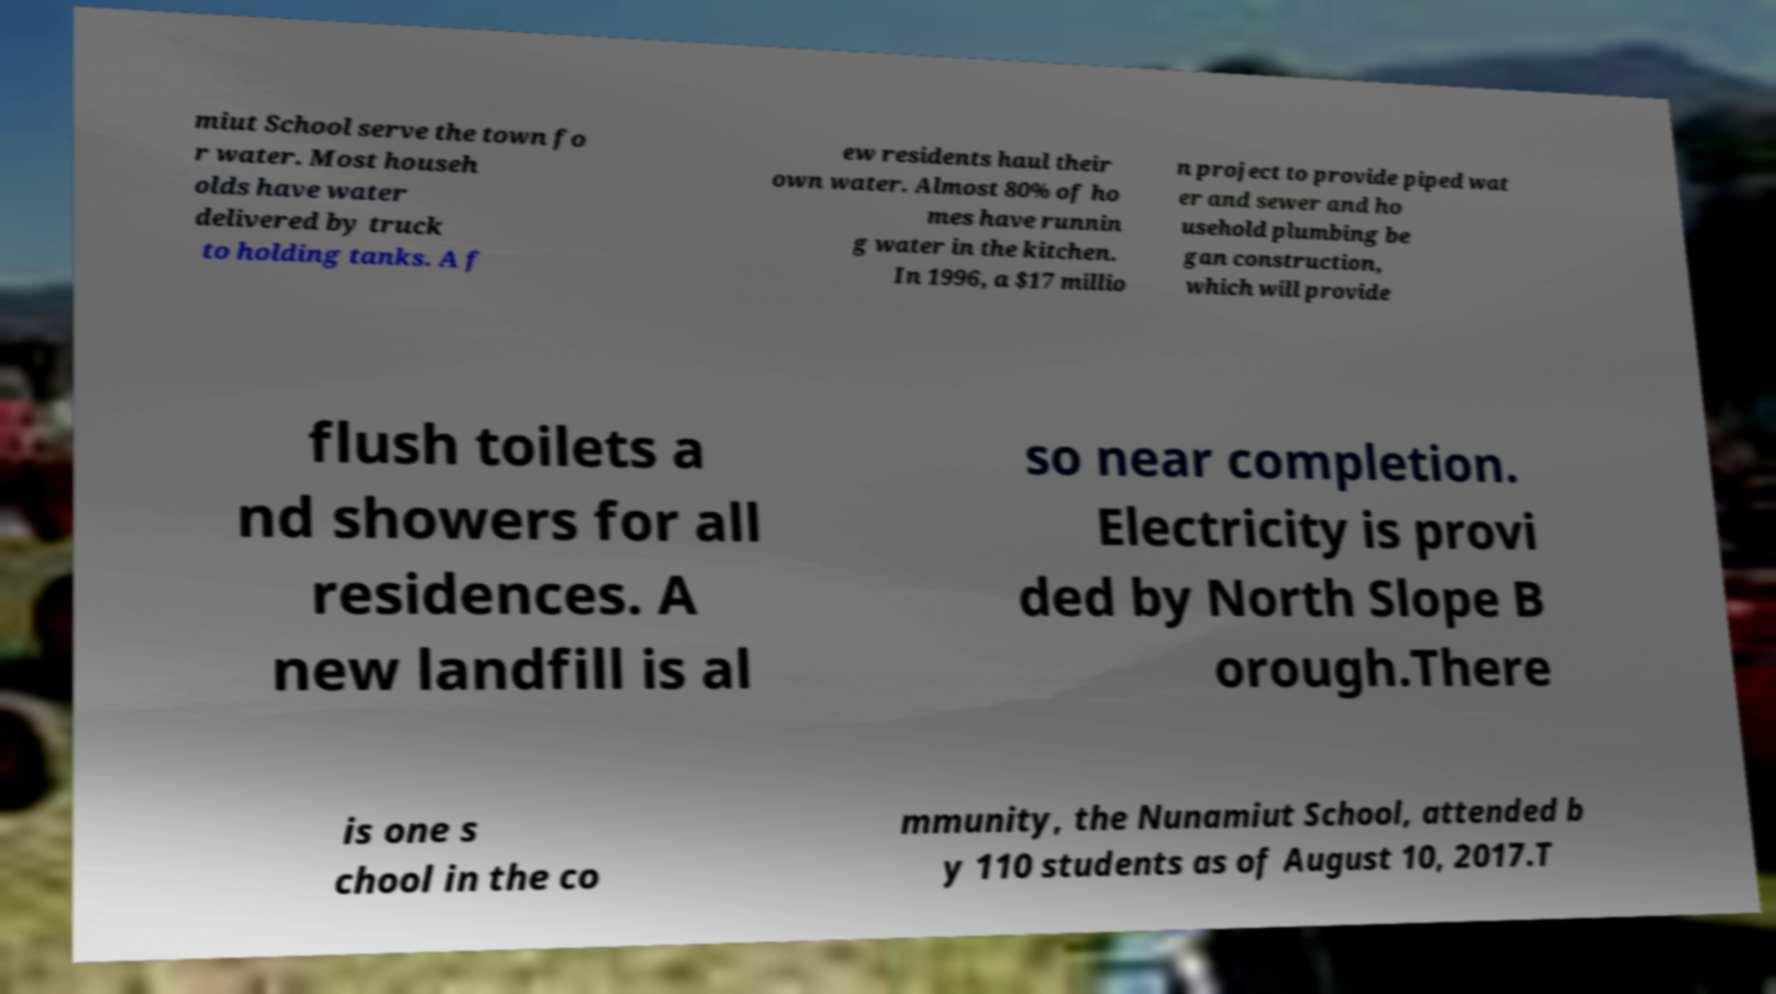What messages or text are displayed in this image? I need them in a readable, typed format. miut School serve the town fo r water. Most househ olds have water delivered by truck to holding tanks. A f ew residents haul their own water. Almost 80% of ho mes have runnin g water in the kitchen. In 1996, a $17 millio n project to provide piped wat er and sewer and ho usehold plumbing be gan construction, which will provide flush toilets a nd showers for all residences. A new landfill is al so near completion. Electricity is provi ded by North Slope B orough.There is one s chool in the co mmunity, the Nunamiut School, attended b y 110 students as of August 10, 2017.T 